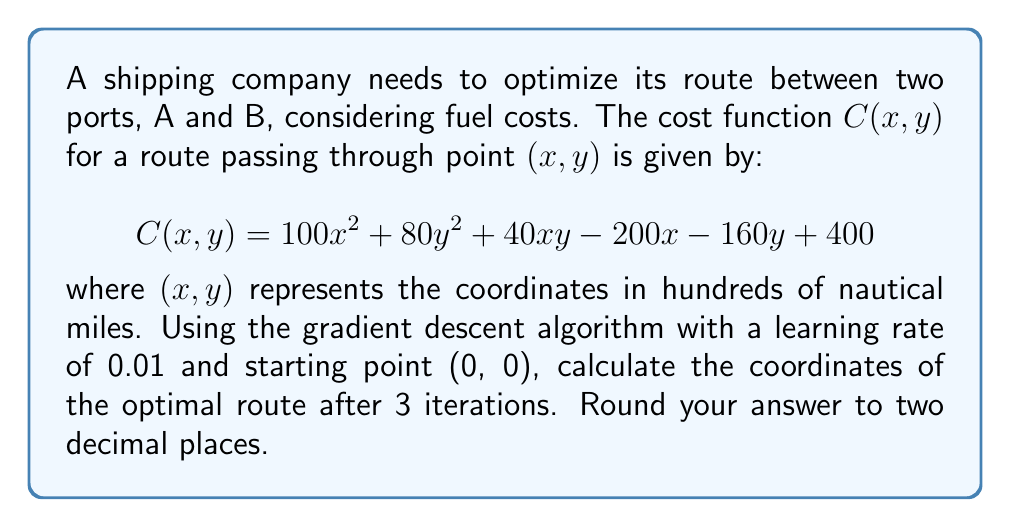Could you help me with this problem? To solve this problem using gradient descent, we'll follow these steps:

1) Calculate the gradient of the cost function:
   $$\nabla C(x, y) = \begin{bmatrix}
   \frac{\partial C}{\partial x} \\
   \frac{\partial C}{\partial y}
   \end{bmatrix} = \begin{bmatrix}
   200x + 40y - 200 \\
   160y + 40x - 160
   \end{bmatrix}$$

2) Initialize the starting point: $(x_0, y_0) = (0, 0)$

3) Update rule for gradient descent:
   $$(x_{n+1}, y_{n+1}) = (x_n, y_n) - 0.01 \cdot \nabla C(x_n, y_n)$$

4) Iteration 1:
   $\nabla C(0, 0) = \begin{bmatrix} -200 \\ -160 \end{bmatrix}$
   $(x_1, y_1) = (0, 0) - 0.01 \cdot \begin{bmatrix} -200 \\ -160 \end{bmatrix} = (2, 1.6)$

5) Iteration 2:
   $\nabla C(2, 1.6) = \begin{bmatrix} 264 \\ 208 \end{bmatrix}$
   $(x_2, y_2) = (2, 1.6) - 0.01 \cdot \begin{bmatrix} 264 \\ 208 \end{bmatrix} = (0.36, 0.52)$

6) Iteration 3:
   $\nabla C(0.36, 0.52) = \begin{bmatrix} -127.2 \\ -98.4 \end{bmatrix}$
   $(x_3, y_3) = (0.36, 0.52) - 0.01 \cdot \begin{bmatrix} -127.2 \\ -98.4 \end{bmatrix} = (1.63, 1.50)$

Rounding to two decimal places, we get (1.63, 1.50).
Answer: (1.63, 1.50) 